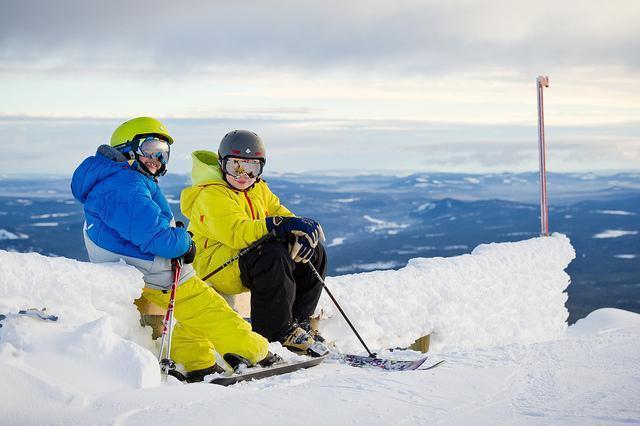How many people are there?
Give a very brief answer. 2. How many blue train cars are there?
Give a very brief answer. 0. 